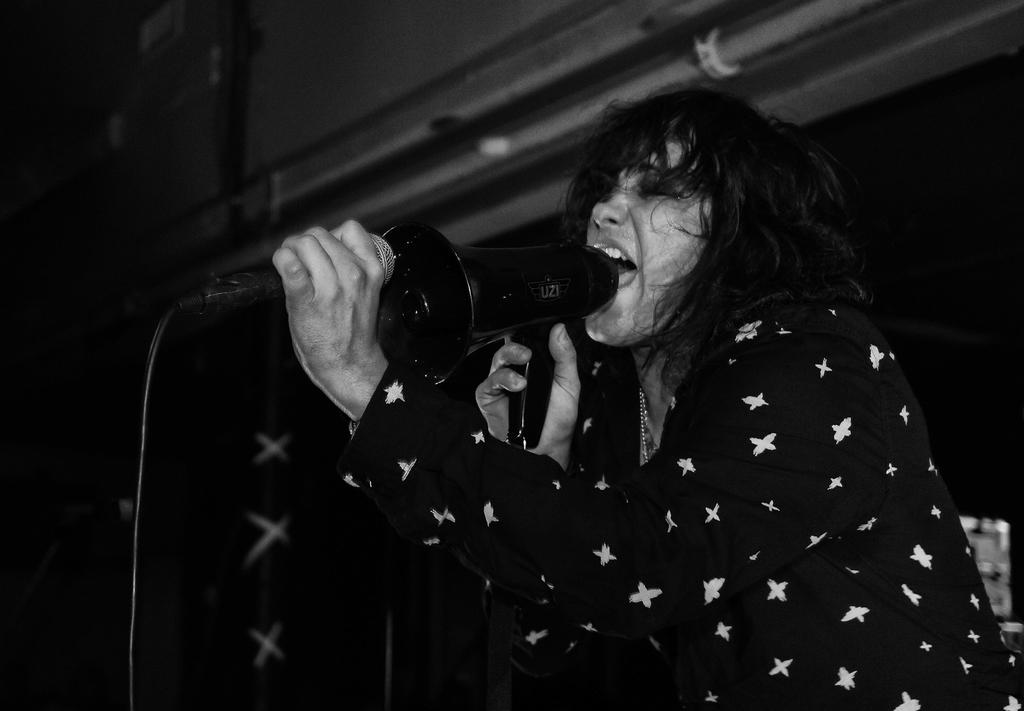What is the color scheme of the image? The image is black and white. Who is present in the image? There is a woman in the image. What is the woman holding in the image? The woman is holding a megaphone and a microphone. What is the woman doing in the image? The woman is singing. Can you describe the background of the image? The background of the image is blurry. Where is the faucet located in the image? There is no faucet present in the image. What type of pie is being served in the image? There is no pie present in the image. 